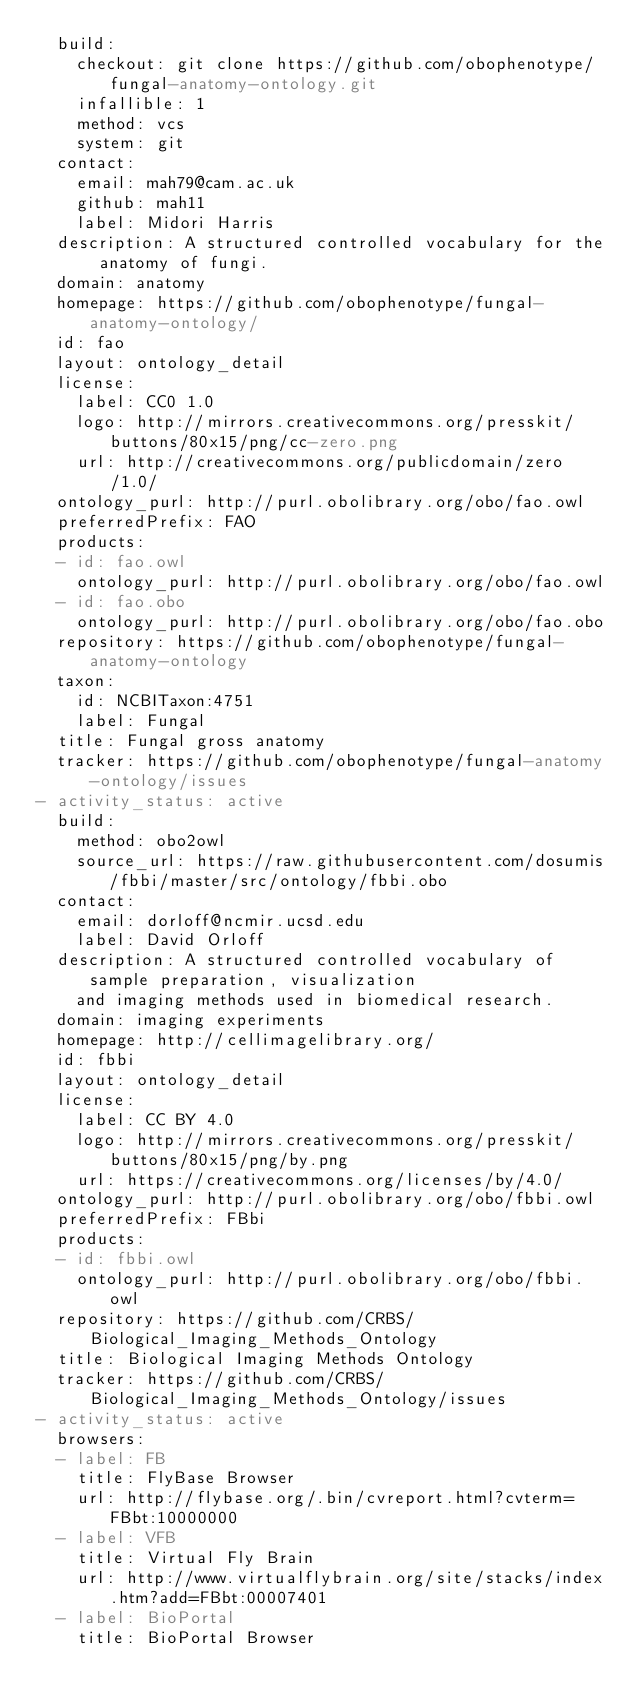<code> <loc_0><loc_0><loc_500><loc_500><_YAML_>  build:
    checkout: git clone https://github.com/obophenotype/fungal-anatomy-ontology.git
    infallible: 1
    method: vcs
    system: git
  contact:
    email: mah79@cam.ac.uk
    github: mah11
    label: Midori Harris
  description: A structured controlled vocabulary for the anatomy of fungi.
  domain: anatomy
  homepage: https://github.com/obophenotype/fungal-anatomy-ontology/
  id: fao
  layout: ontology_detail
  license:
    label: CC0 1.0
    logo: http://mirrors.creativecommons.org/presskit/buttons/80x15/png/cc-zero.png
    url: http://creativecommons.org/publicdomain/zero/1.0/
  ontology_purl: http://purl.obolibrary.org/obo/fao.owl
  preferredPrefix: FAO
  products:
  - id: fao.owl
    ontology_purl: http://purl.obolibrary.org/obo/fao.owl
  - id: fao.obo
    ontology_purl: http://purl.obolibrary.org/obo/fao.obo
  repository: https://github.com/obophenotype/fungal-anatomy-ontology
  taxon:
    id: NCBITaxon:4751
    label: Fungal
  title: Fungal gross anatomy
  tracker: https://github.com/obophenotype/fungal-anatomy-ontology/issues
- activity_status: active
  build:
    method: obo2owl
    source_url: https://raw.githubusercontent.com/dosumis/fbbi/master/src/ontology/fbbi.obo
  contact:
    email: dorloff@ncmir.ucsd.edu
    label: David Orloff
  description: A structured controlled vocabulary of sample preparation, visualization
    and imaging methods used in biomedical research.
  domain: imaging experiments
  homepage: http://cellimagelibrary.org/
  id: fbbi
  layout: ontology_detail
  license:
    label: CC BY 4.0
    logo: http://mirrors.creativecommons.org/presskit/buttons/80x15/png/by.png
    url: https://creativecommons.org/licenses/by/4.0/
  ontology_purl: http://purl.obolibrary.org/obo/fbbi.owl
  preferredPrefix: FBbi
  products:
  - id: fbbi.owl
    ontology_purl: http://purl.obolibrary.org/obo/fbbi.owl
  repository: https://github.com/CRBS/Biological_Imaging_Methods_Ontology
  title: Biological Imaging Methods Ontology
  tracker: https://github.com/CRBS/Biological_Imaging_Methods_Ontology/issues
- activity_status: active
  browsers:
  - label: FB
    title: FlyBase Browser
    url: http://flybase.org/.bin/cvreport.html?cvterm=FBbt:10000000
  - label: VFB
    title: Virtual Fly Brain
    url: http://www.virtualflybrain.org/site/stacks/index.htm?add=FBbt:00007401
  - label: BioPortal
    title: BioPortal Browser</code> 